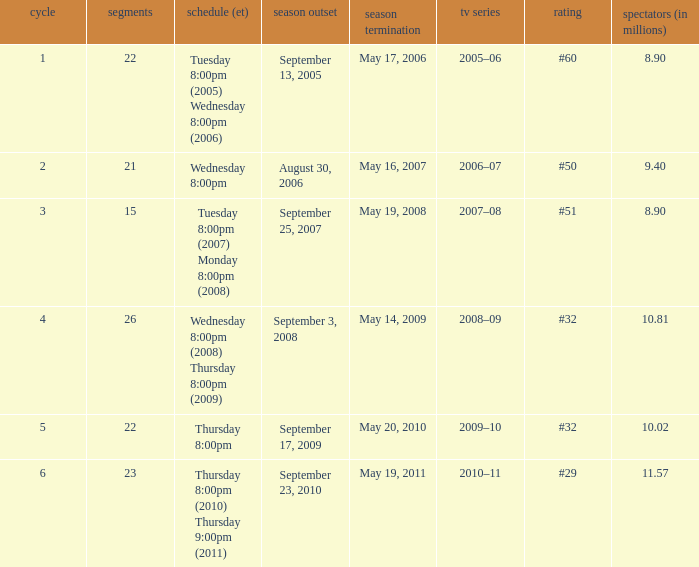What tv season was episode 23 broadcast? 2010–11. 